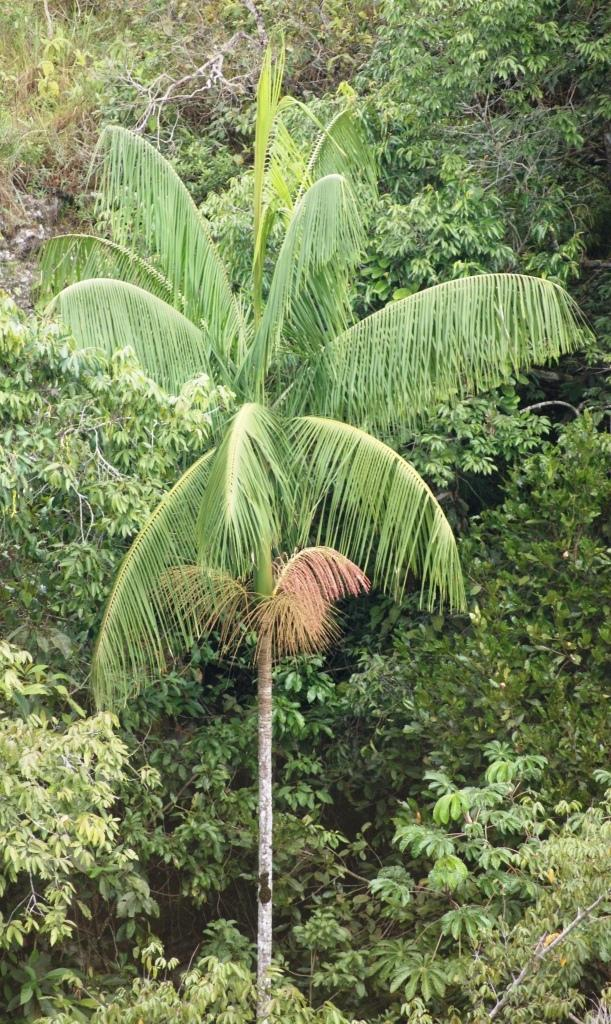What is the main subject in the foreground of the image? There is a tree in the foreground of the image. How does the tree in the foreground compare to the other trees in the image? The tree in the foreground is the largest in the image. What is the surrounding area of the large tree like? The large tree is surrounded by many other trees. Can you describe the detail of the person's face in the image? There is no person present in the image, so it is not possible to describe the detail of their face. 